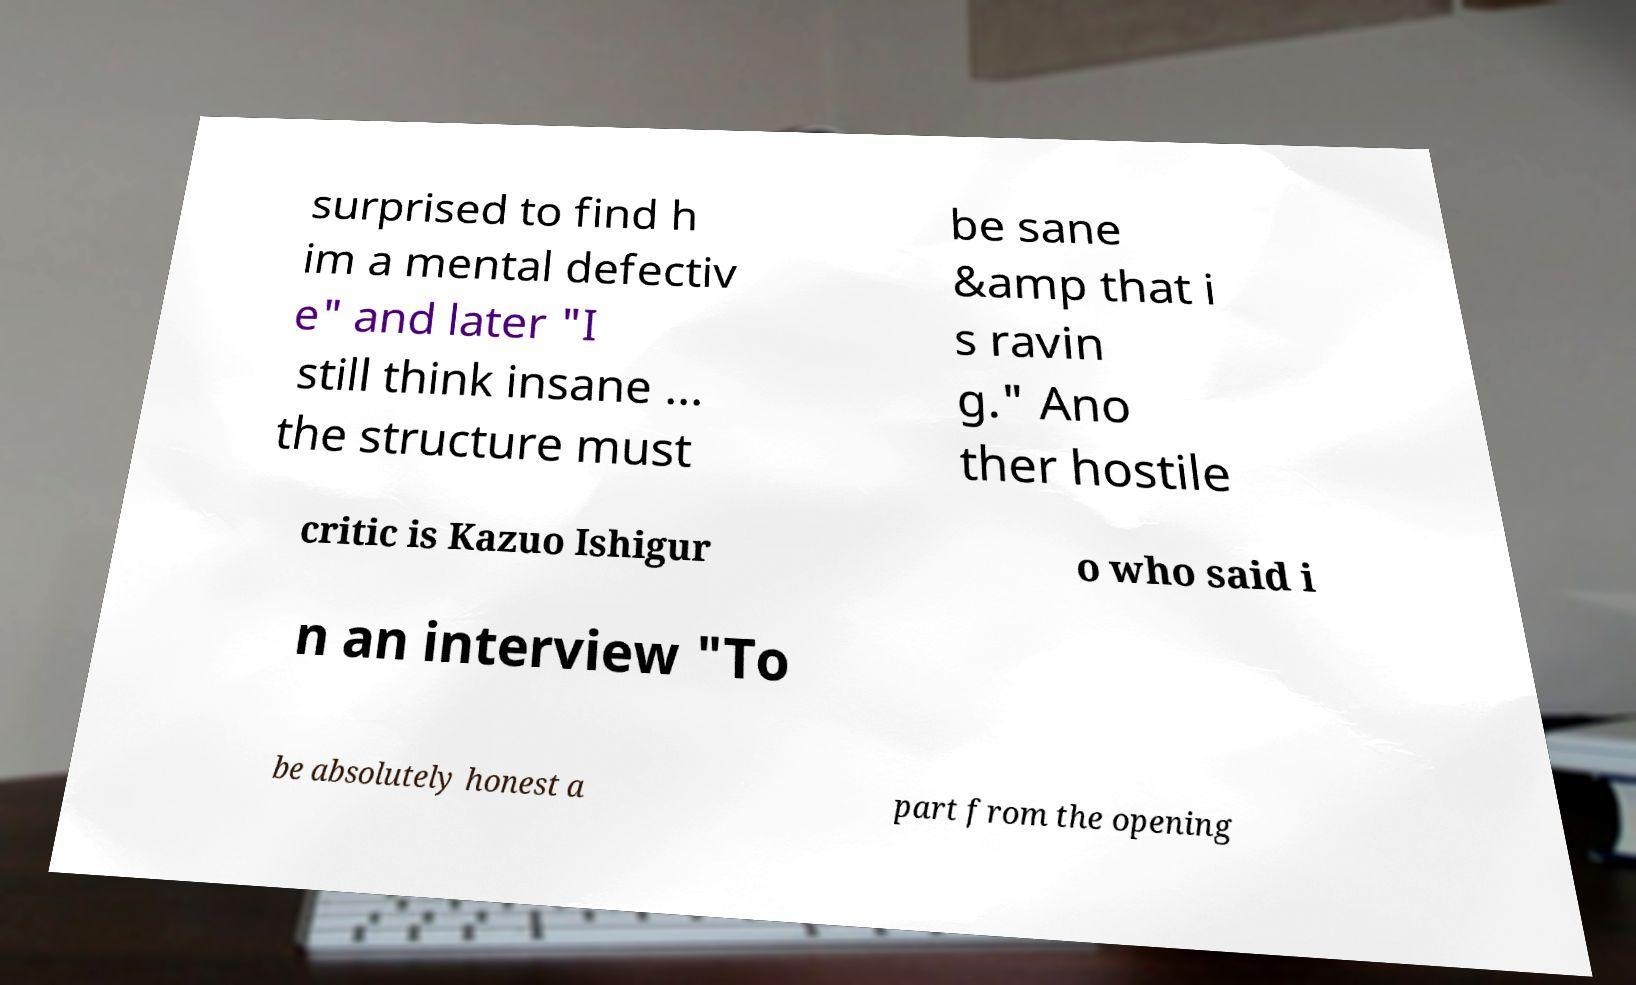I need the written content from this picture converted into text. Can you do that? surprised to find h im a mental defectiv e" and later "I still think insane ... the structure must be sane &amp that i s ravin g." Ano ther hostile critic is Kazuo Ishigur o who said i n an interview "To be absolutely honest a part from the opening 